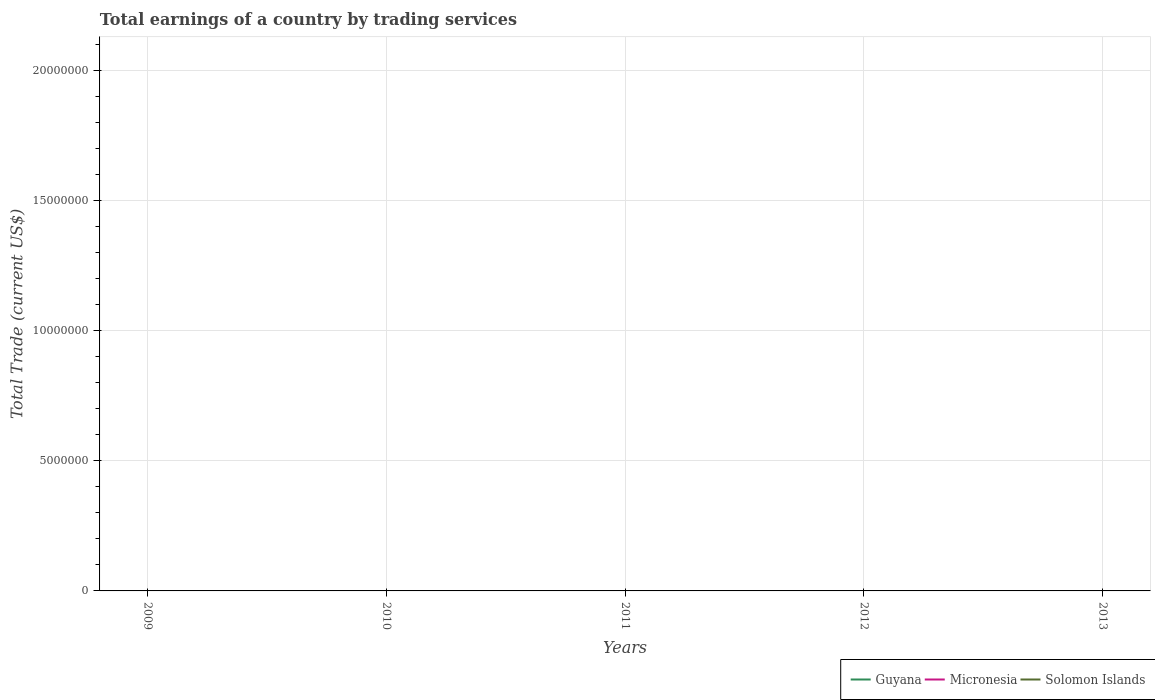How many different coloured lines are there?
Offer a very short reply. 0. Across all years, what is the maximum total earnings in Solomon Islands?
Your response must be concise. 0. What is the difference between the highest and the lowest total earnings in Solomon Islands?
Give a very brief answer. 0. Is the total earnings in Micronesia strictly greater than the total earnings in Solomon Islands over the years?
Provide a succinct answer. No. How many lines are there?
Provide a succinct answer. 0. How are the legend labels stacked?
Provide a succinct answer. Horizontal. What is the title of the graph?
Keep it short and to the point. Total earnings of a country by trading services. What is the label or title of the Y-axis?
Give a very brief answer. Total Trade (current US$). What is the Total Trade (current US$) of Guyana in 2009?
Give a very brief answer. 0. What is the Total Trade (current US$) of Solomon Islands in 2009?
Your response must be concise. 0. What is the Total Trade (current US$) in Micronesia in 2010?
Offer a terse response. 0. What is the Total Trade (current US$) in Solomon Islands in 2010?
Offer a very short reply. 0. What is the Total Trade (current US$) in Micronesia in 2013?
Make the answer very short. 0. What is the Total Trade (current US$) in Solomon Islands in 2013?
Provide a short and direct response. 0. What is the total Total Trade (current US$) in Micronesia in the graph?
Provide a succinct answer. 0. What is the total Total Trade (current US$) in Solomon Islands in the graph?
Give a very brief answer. 0. What is the average Total Trade (current US$) of Micronesia per year?
Keep it short and to the point. 0. 